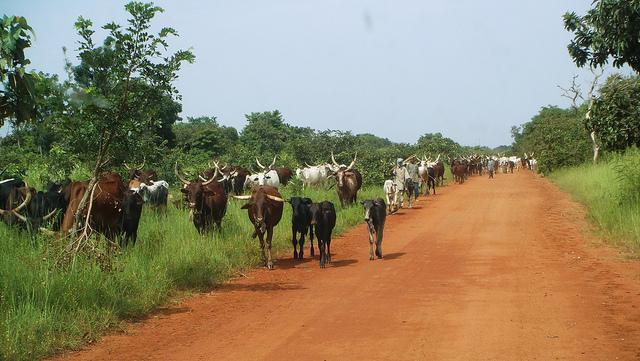How many cows are in the photo?
Give a very brief answer. 3. How many people are wearing orange glasses?
Give a very brief answer. 0. 